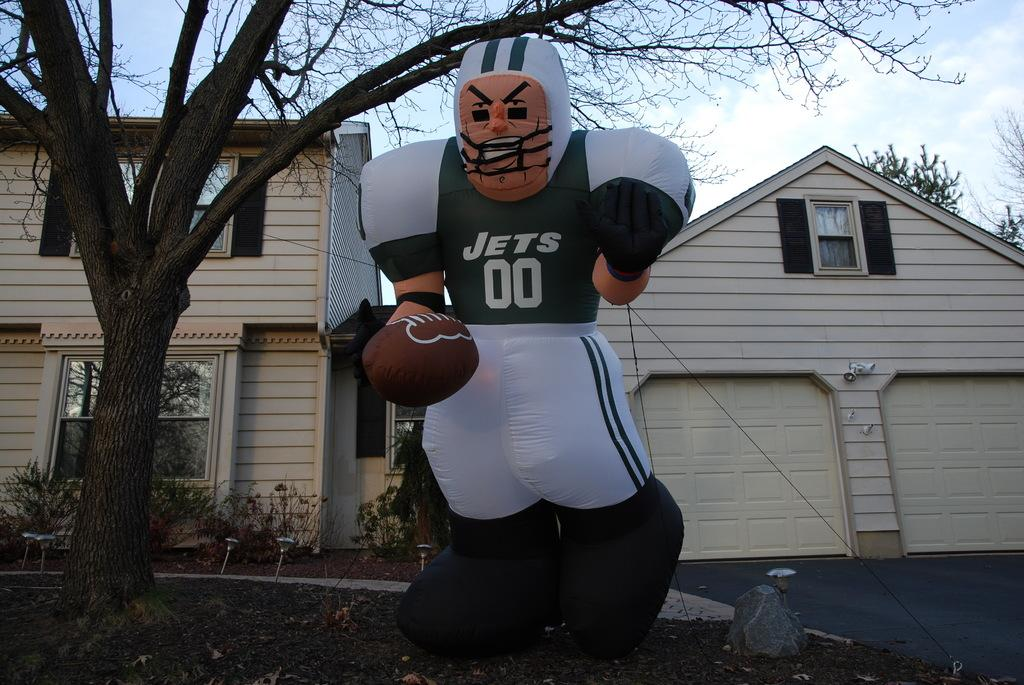Provide a one-sentence caption for the provided image. A blow up doll with the words Jets and the number 00 on his chest hangs from a tree. 